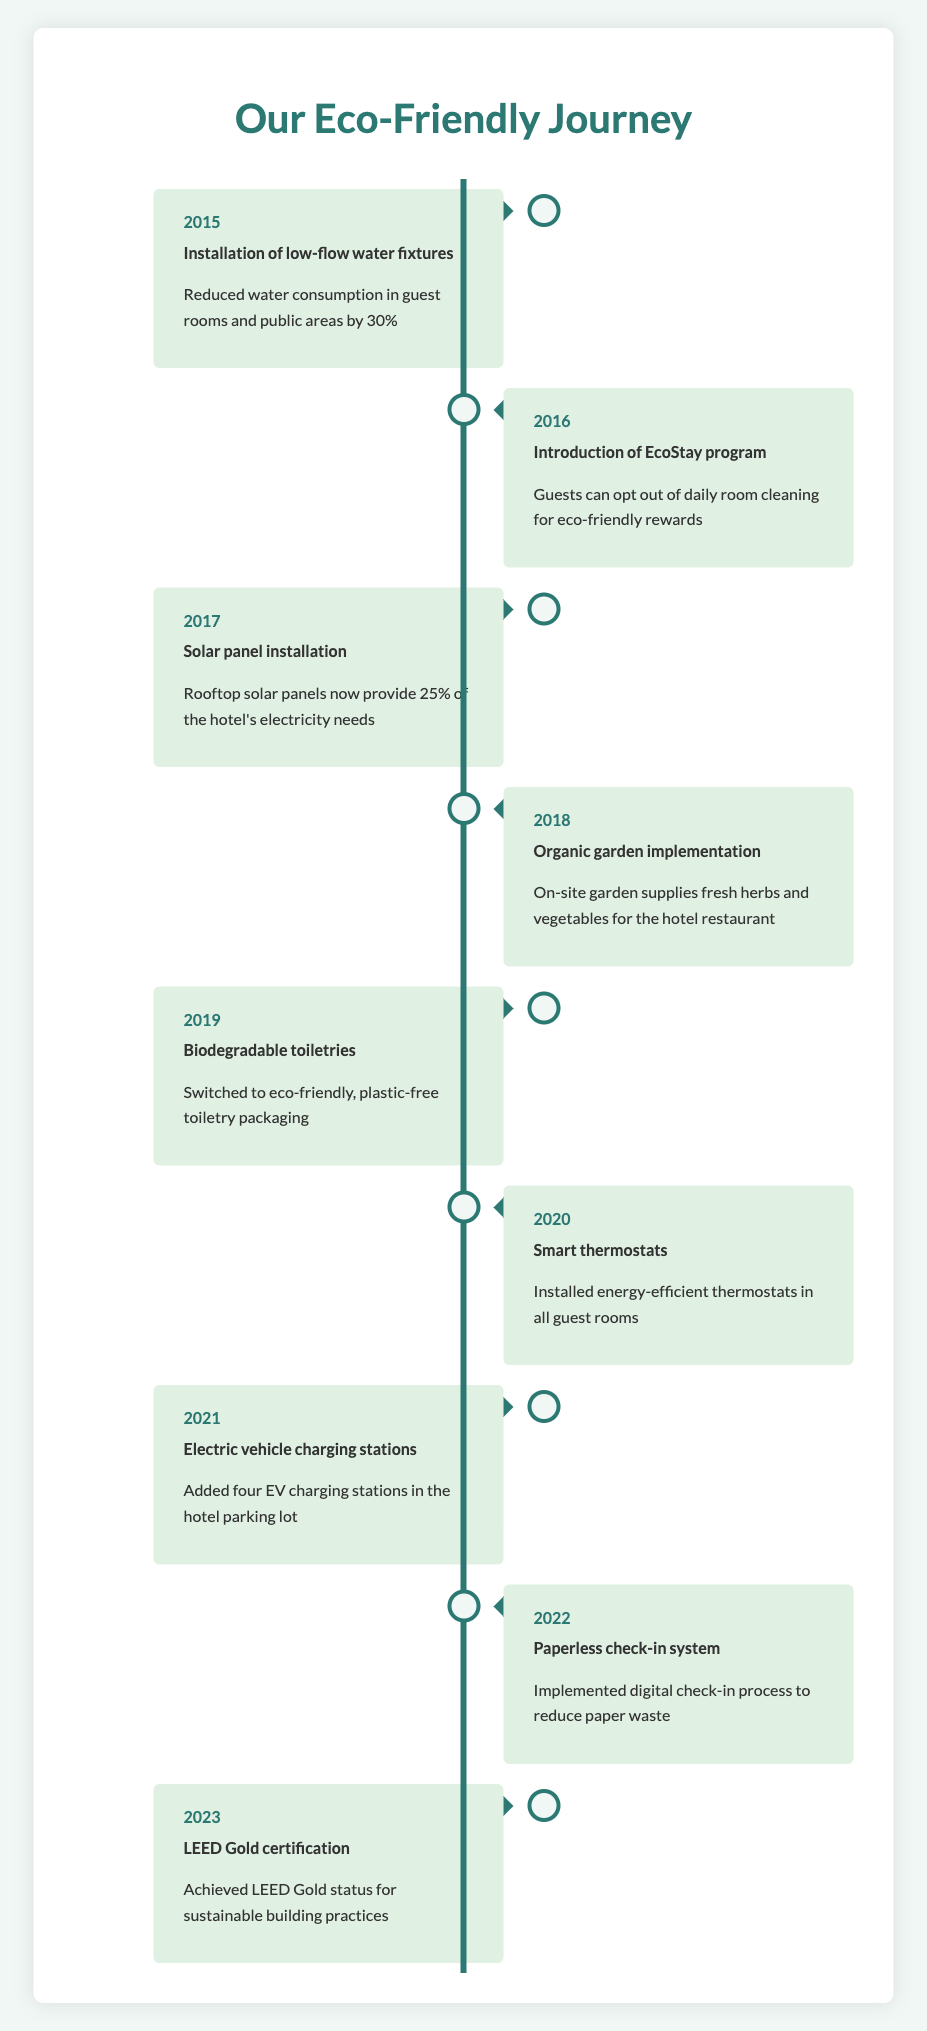What sustainability initiative was first implemented by the hotel? The first initiative listed is the "Installation of low-flow water fixtures" in 2015. The table clearly shows the chronological order of initiatives, starting from 2015.
Answer: Installation of low-flow water fixtures Which year did the hotel achieve LEED Gold certification? The table indicates that the hotel achieved LEED Gold certification in 2023. This is the last entry in the timeline.
Answer: 2023 How many years were there between the Solar panel installation and the Organic garden implementation? Solar panel installation occurred in 2017, and Organic garden implementation was in 2018. The difference between these two years is one year.
Answer: 1 Did the hotel switch to biodegradable toiletries before implementing the Smart thermostats? Yes, the hotel switched to biodegradable toiletries in 2019, which is before they implemented Smart thermostats in 2020. This can be verified by looking at the year listed with each initiative.
Answer: Yes What percentage of the hotel's electricity needs is provided by the solar panels? The section about the solar panel installation states that they provide 25% of the hotel's electricity needs. This is explicitly mentioned in the description.
Answer: 25% How many eco-friendly initiatives were implemented from 2015 to 2022? Counting the listed initiatives from 2015 to 2022, there are a total of eight initiatives in that range: 2015, 2016, 2017, 2018, 2019, 2020, 2021, and 2022. This involves simply counting the entries for each year in the specified range.
Answer: 8 What was the purpose of the EcoStay program introduced in 2016? The EcoStay program incentivizes guests to opt-out of daily room cleaning in exchange for eco-friendly rewards. This is clearly stated in the description for the 2016 initiative.
Answer: Incentivize opting out of daily room cleaning for rewards Which initiative immediately followed the installation of electric vehicle charging stations? The paperless check-in system was implemented in 2022, which is immediately following the addition of electric vehicle charging stations in 2021. This requires checking the year of each initiative in order.
Answer: Paperless check-in system Is the installation of biodegradable toiletries the only initiative related to toiletries? Yes, switching to biodegradable toiletries is the only initiative mentioned specifically related to toiletries in the table. No other initiatives reference toiletries.
Answer: Yes 